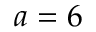<formula> <loc_0><loc_0><loc_500><loc_500>a = 6</formula> 